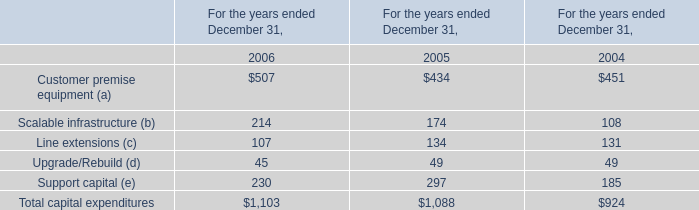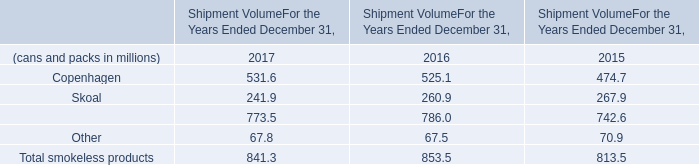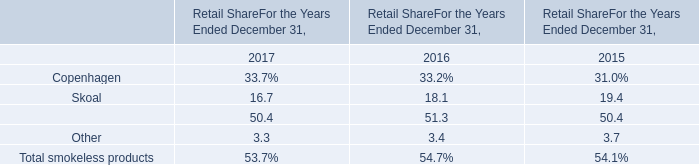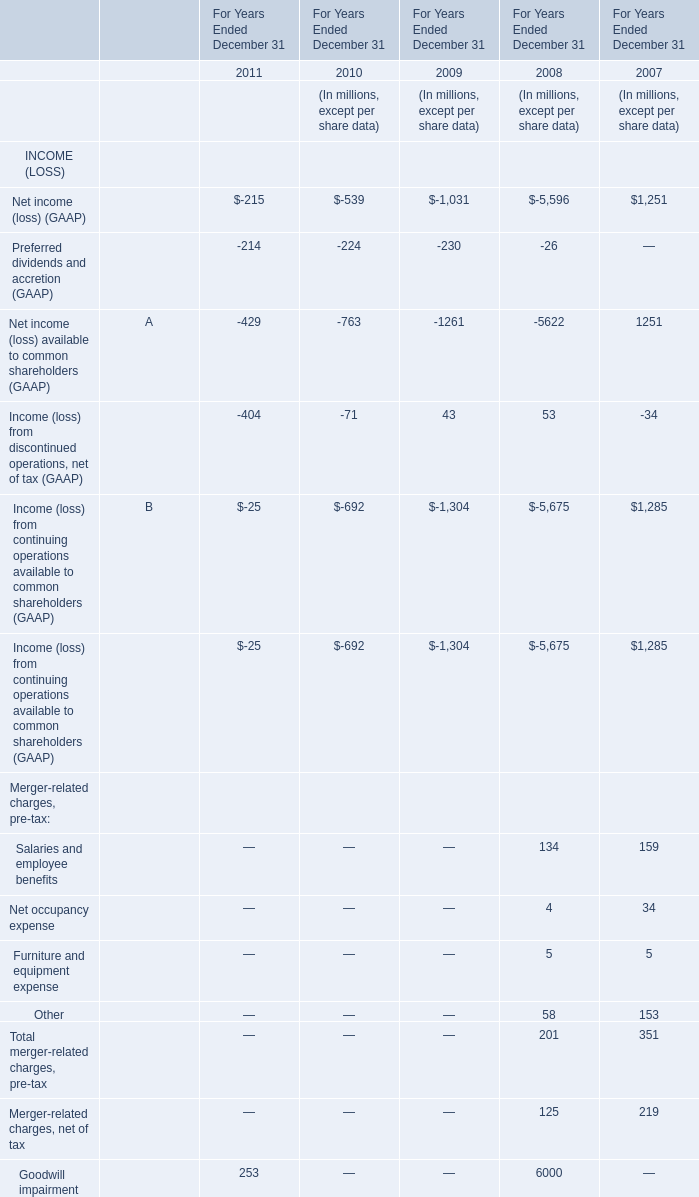What is the sum of Total capital expenditures in 2005 and CopenhagenandSkoal in 2016? (in million) 
Computations: (1088 + 786)
Answer: 1874.0. 